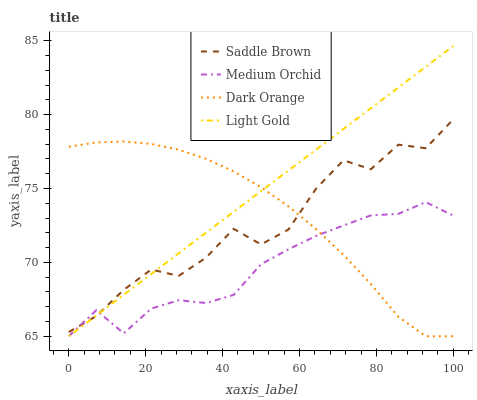Does Medium Orchid have the minimum area under the curve?
Answer yes or no. Yes. Does Light Gold have the maximum area under the curve?
Answer yes or no. Yes. Does Light Gold have the minimum area under the curve?
Answer yes or no. No. Does Medium Orchid have the maximum area under the curve?
Answer yes or no. No. Is Light Gold the smoothest?
Answer yes or no. Yes. Is Saddle Brown the roughest?
Answer yes or no. Yes. Is Medium Orchid the smoothest?
Answer yes or no. No. Is Medium Orchid the roughest?
Answer yes or no. No. Does Saddle Brown have the lowest value?
Answer yes or no. No. Does Light Gold have the highest value?
Answer yes or no. Yes. Does Medium Orchid have the highest value?
Answer yes or no. No. Does Light Gold intersect Medium Orchid?
Answer yes or no. Yes. Is Light Gold less than Medium Orchid?
Answer yes or no. No. Is Light Gold greater than Medium Orchid?
Answer yes or no. No. 